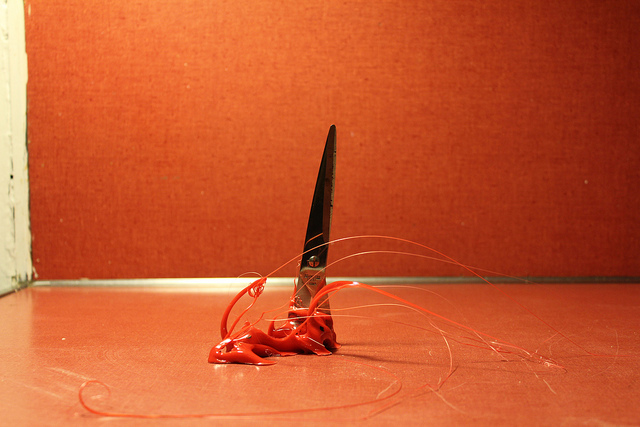<image>What did this used to be? It is ambiguous what this used to be. It could have been paper, paint, scissors, plastic, or candy. What did this used to be? I am not sure what this used to be. It can be seen as 'paper', 'scissors' or 'gnome'. 